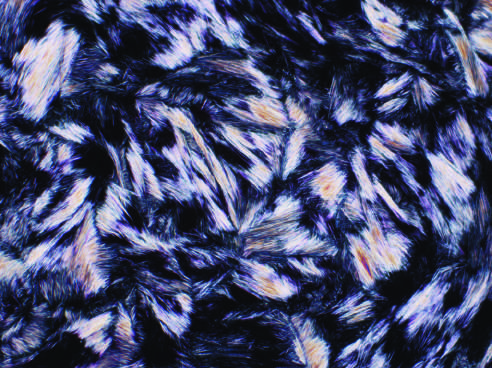re urate crystals needle shaped and negatively birefringent under polarized light?
Answer the question using a single word or phrase. Yes 